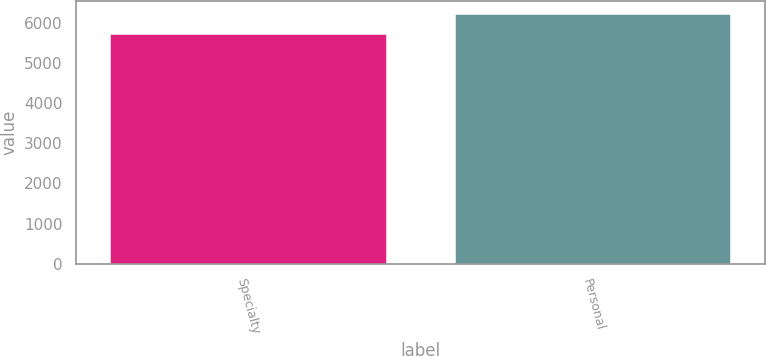Convert chart. <chart><loc_0><loc_0><loc_500><loc_500><bar_chart><fcel>Specialty<fcel>Personal<nl><fcel>5729<fcel>6228<nl></chart> 